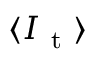<formula> <loc_0><loc_0><loc_500><loc_500>\langle I _ { t } \rangle</formula> 